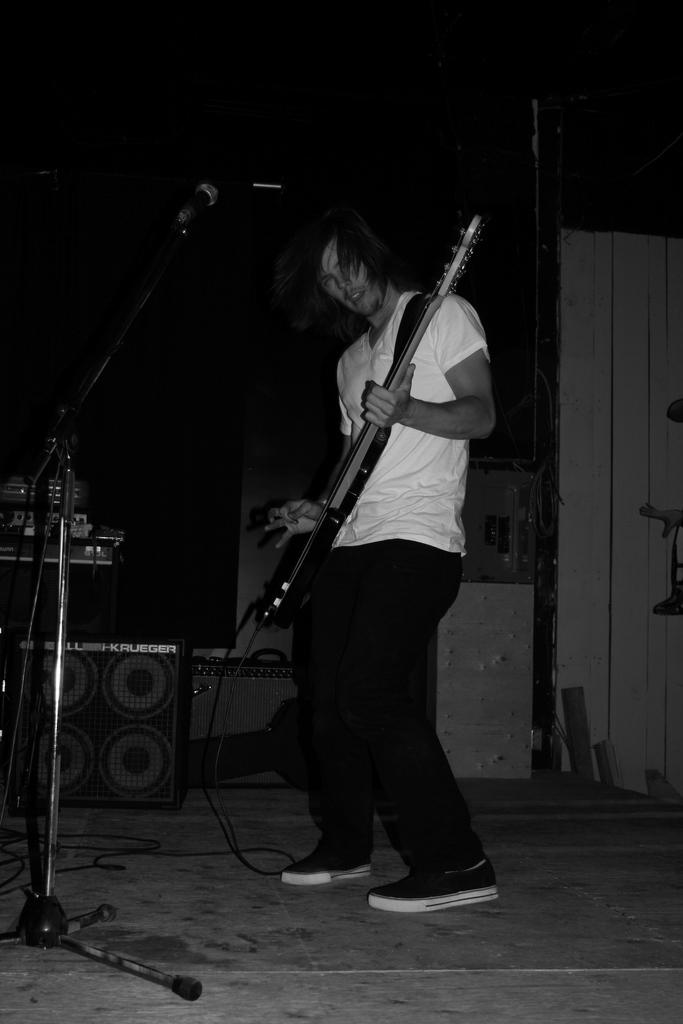What is the man in the image doing? The man is playing a guitar in the image. What equipment is visible near the man? There is a microphone and its stand on the left side of the image, and a speaker behind the microphone and its stand. How many sheep can be seen in the image? There are no sheep present in the image. What discovery was made during the recording session in the image? There is no indication of a recording session or any discovery in the image. 